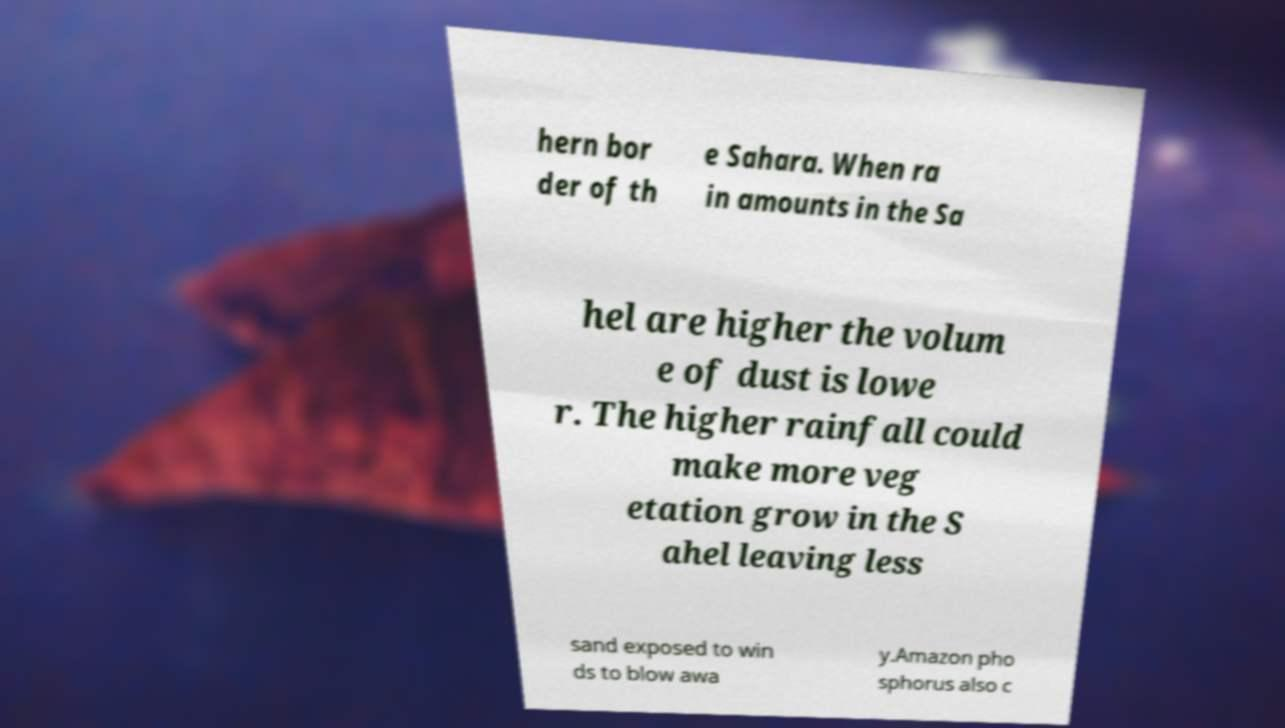Please identify and transcribe the text found in this image. hern bor der of th e Sahara. When ra in amounts in the Sa hel are higher the volum e of dust is lowe r. The higher rainfall could make more veg etation grow in the S ahel leaving less sand exposed to win ds to blow awa y.Amazon pho sphorus also c 